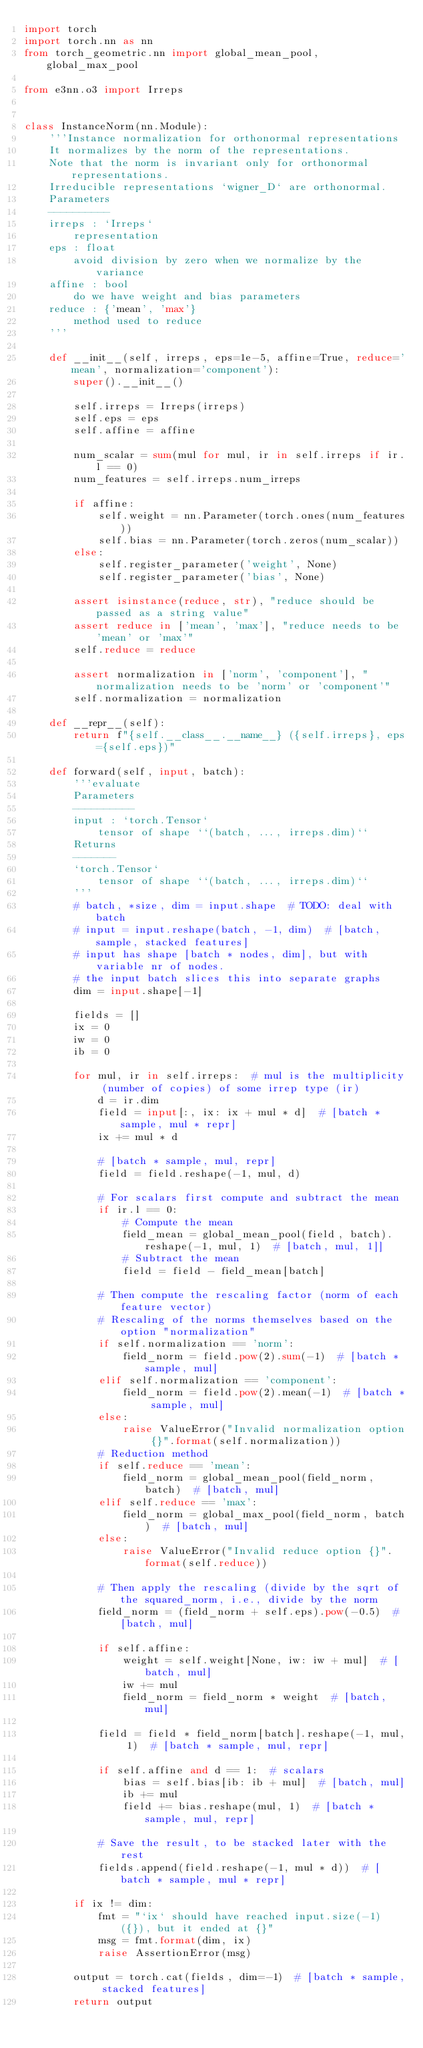<code> <loc_0><loc_0><loc_500><loc_500><_Python_>import torch
import torch.nn as nn
from torch_geometric.nn import global_mean_pool, global_max_pool

from e3nn.o3 import Irreps


class InstanceNorm(nn.Module):
    '''Instance normalization for orthonormal representations
    It normalizes by the norm of the representations.
    Note that the norm is invariant only for orthonormal representations.
    Irreducible representations `wigner_D` are orthonormal.
    Parameters
    ----------
    irreps : `Irreps`
        representation
    eps : float
        avoid division by zero when we normalize by the variance
    affine : bool
        do we have weight and bias parameters
    reduce : {'mean', 'max'}
        method used to reduce
    '''

    def __init__(self, irreps, eps=1e-5, affine=True, reduce='mean', normalization='component'):
        super().__init__()

        self.irreps = Irreps(irreps)
        self.eps = eps
        self.affine = affine

        num_scalar = sum(mul for mul, ir in self.irreps if ir.l == 0)
        num_features = self.irreps.num_irreps

        if affine:
            self.weight = nn.Parameter(torch.ones(num_features))
            self.bias = nn.Parameter(torch.zeros(num_scalar))
        else:
            self.register_parameter('weight', None)
            self.register_parameter('bias', None)

        assert isinstance(reduce, str), "reduce should be passed as a string value"
        assert reduce in ['mean', 'max'], "reduce needs to be 'mean' or 'max'"
        self.reduce = reduce

        assert normalization in ['norm', 'component'], "normalization needs to be 'norm' or 'component'"
        self.normalization = normalization

    def __repr__(self):
        return f"{self.__class__.__name__} ({self.irreps}, eps={self.eps})"

    def forward(self, input, batch):
        '''evaluate
        Parameters
        ----------
        input : `torch.Tensor`
            tensor of shape ``(batch, ..., irreps.dim)``
        Returns
        -------
        `torch.Tensor`
            tensor of shape ``(batch, ..., irreps.dim)``
        '''
        # batch, *size, dim = input.shape  # TODO: deal with batch
        # input = input.reshape(batch, -1, dim)  # [batch, sample, stacked features]
        # input has shape [batch * nodes, dim], but with variable nr of nodes.
        # the input batch slices this into separate graphs
        dim = input.shape[-1]

        fields = []
        ix = 0
        iw = 0
        ib = 0

        for mul, ir in self.irreps:  # mul is the multiplicity (number of copies) of some irrep type (ir)
            d = ir.dim
            field = input[:, ix: ix + mul * d]  # [batch * sample, mul * repr]
            ix += mul * d

            # [batch * sample, mul, repr]
            field = field.reshape(-1, mul, d)

            # For scalars first compute and subtract the mean
            if ir.l == 0:
                # Compute the mean
                field_mean = global_mean_pool(field, batch).reshape(-1, mul, 1)  # [batch, mul, 1]]
                # Subtract the mean
                field = field - field_mean[batch]

            # Then compute the rescaling factor (norm of each feature vector)
            # Rescaling of the norms themselves based on the option "normalization"
            if self.normalization == 'norm':
                field_norm = field.pow(2).sum(-1)  # [batch * sample, mul]
            elif self.normalization == 'component':
                field_norm = field.pow(2).mean(-1)  # [batch * sample, mul]
            else:
                raise ValueError("Invalid normalization option {}".format(self.normalization))
            # Reduction method
            if self.reduce == 'mean':
                field_norm = global_mean_pool(field_norm, batch)  # [batch, mul]
            elif self.reduce == 'max':
                field_norm = global_max_pool(field_norm, batch)  # [batch, mul]
            else:
                raise ValueError("Invalid reduce option {}".format(self.reduce))

            # Then apply the rescaling (divide by the sqrt of the squared_norm, i.e., divide by the norm
            field_norm = (field_norm + self.eps).pow(-0.5)  # [batch, mul]

            if self.affine:
                weight = self.weight[None, iw: iw + mul]  # [batch, mul]
                iw += mul
                field_norm = field_norm * weight  # [batch, mul]

            field = field * field_norm[batch].reshape(-1, mul, 1)  # [batch * sample, mul, repr]

            if self.affine and d == 1:  # scalars
                bias = self.bias[ib: ib + mul]  # [batch, mul]
                ib += mul
                field += bias.reshape(mul, 1)  # [batch * sample, mul, repr]

            # Save the result, to be stacked later with the rest
            fields.append(field.reshape(-1, mul * d))  # [batch * sample, mul * repr]

        if ix != dim:
            fmt = "`ix` should have reached input.size(-1) ({}), but it ended at {}"
            msg = fmt.format(dim, ix)
            raise AssertionError(msg)

        output = torch.cat(fields, dim=-1)  # [batch * sample, stacked features]
        return output
</code> 